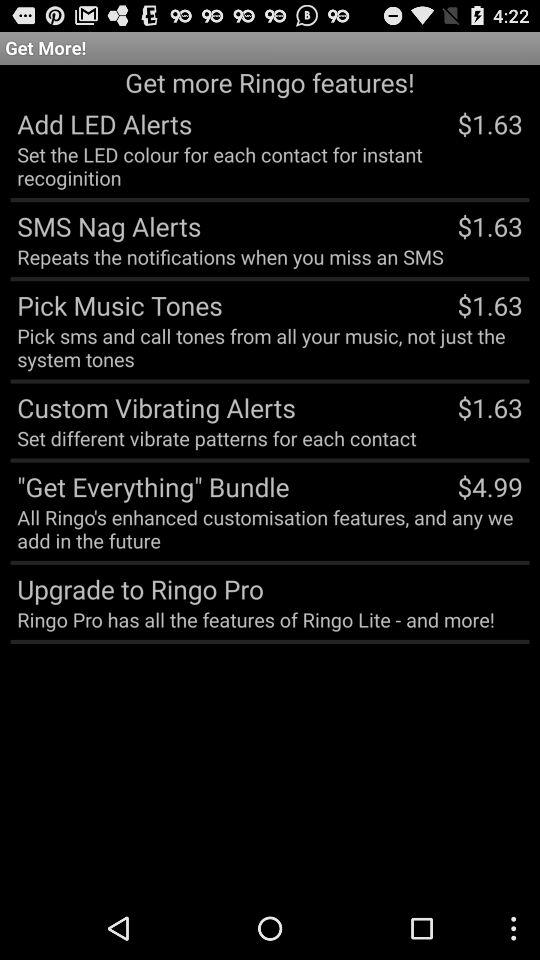What is the price of "ADD LED Alerts"? The price is $1.63. 